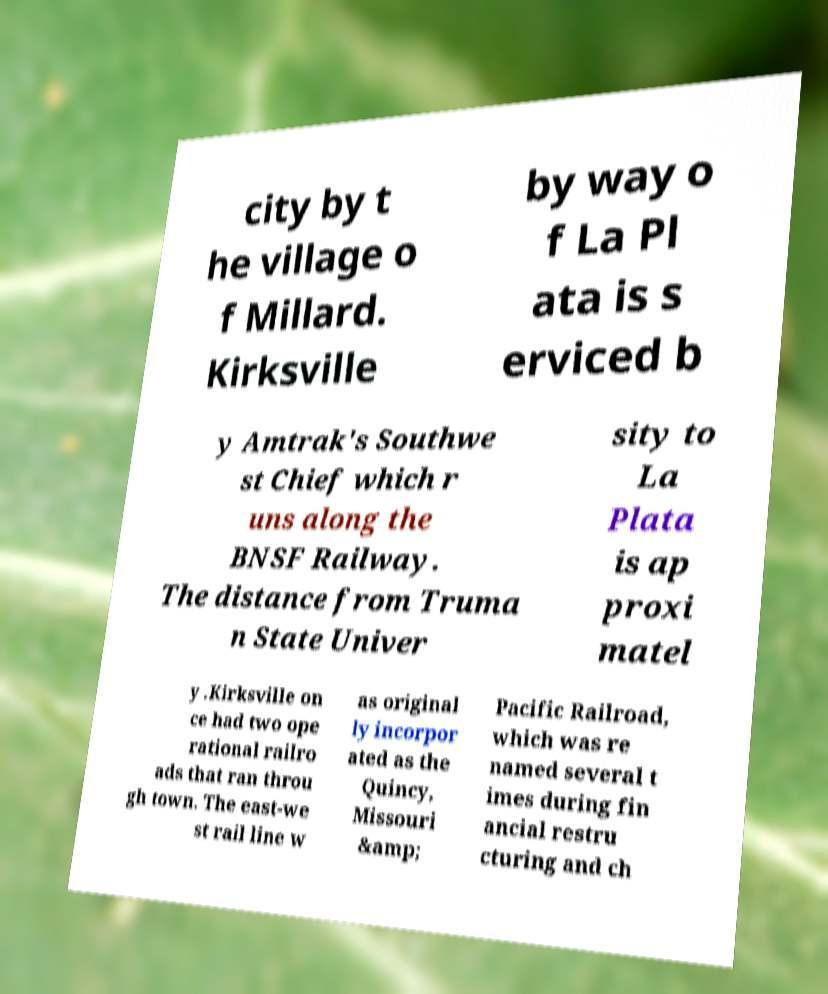Could you assist in decoding the text presented in this image and type it out clearly? city by t he village o f Millard. Kirksville by way o f La Pl ata is s erviced b y Amtrak's Southwe st Chief which r uns along the BNSF Railway. The distance from Truma n State Univer sity to La Plata is ap proxi matel y .Kirksville on ce had two ope rational railro ads that ran throu gh town. The east-we st rail line w as original ly incorpor ated as the Quincy, Missouri &amp; Pacific Railroad, which was re named several t imes during fin ancial restru cturing and ch 